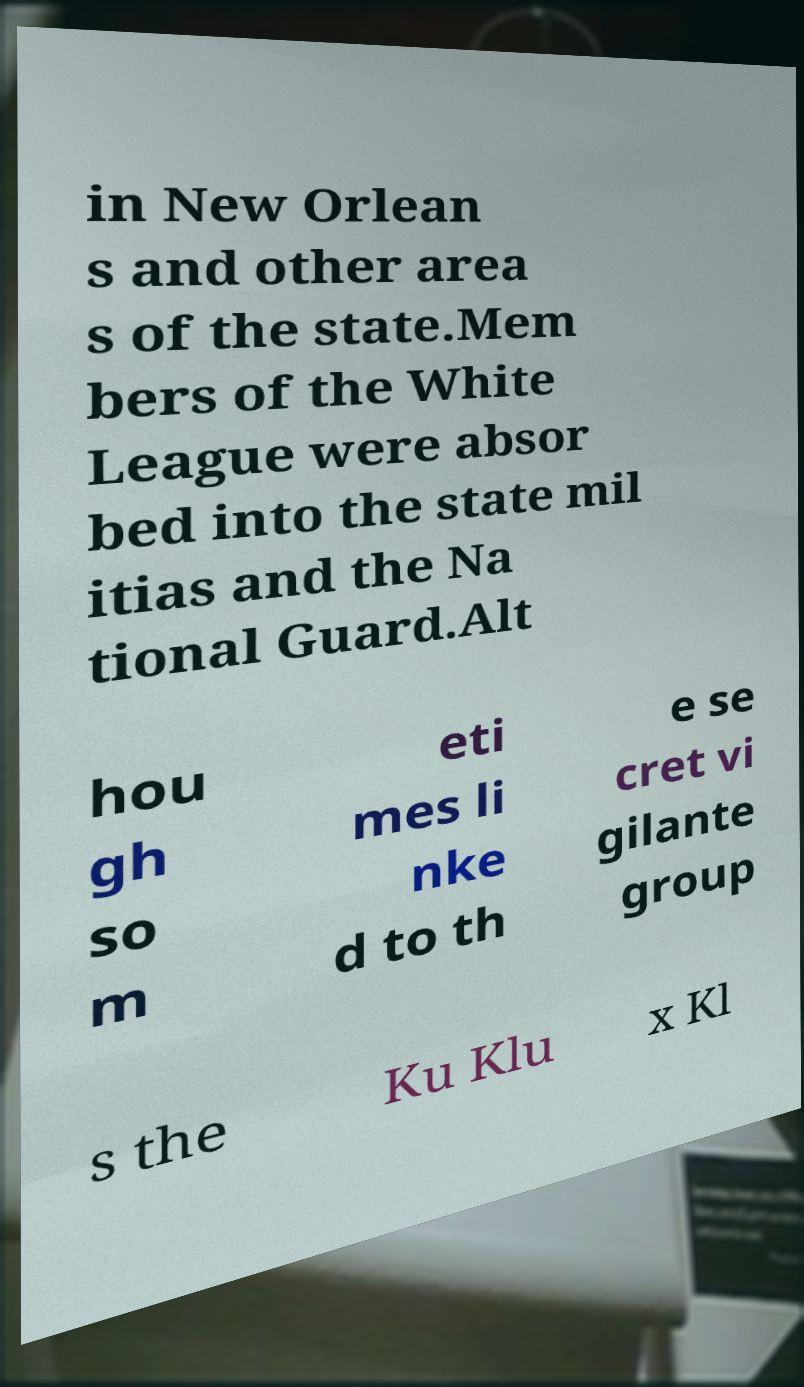Can you accurately transcribe the text from the provided image for me? in New Orlean s and other area s of the state.Mem bers of the White League were absor bed into the state mil itias and the Na tional Guard.Alt hou gh so m eti mes li nke d to th e se cret vi gilante group s the Ku Klu x Kl 